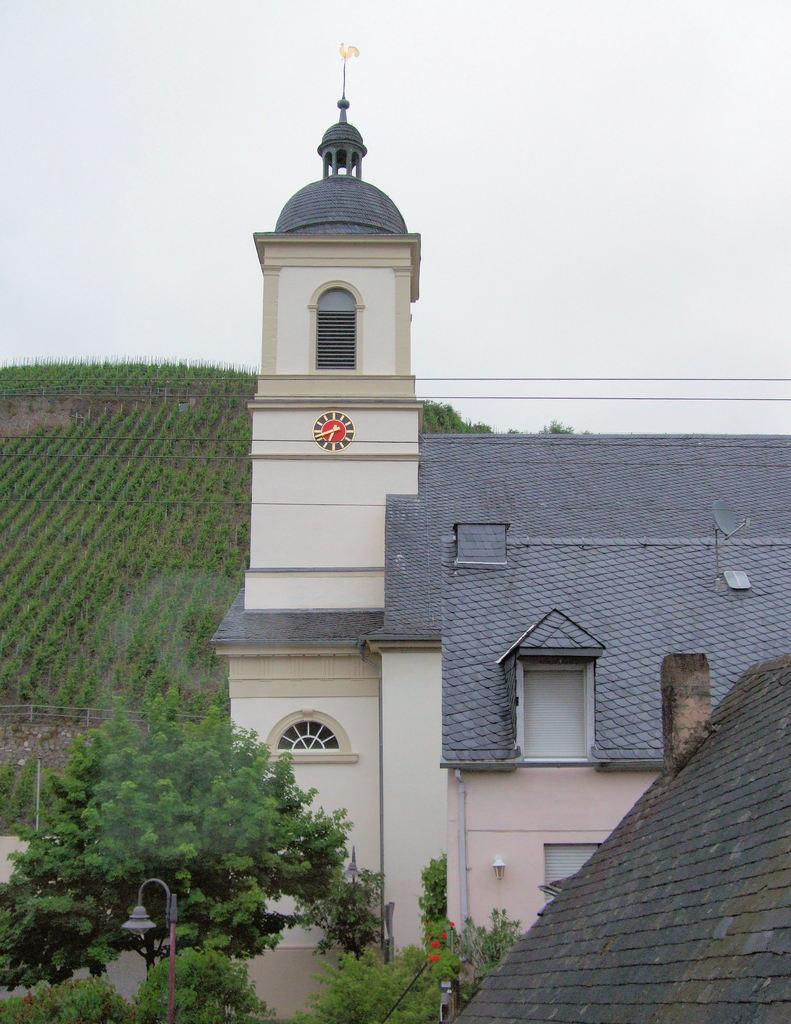What type of structures can be seen in the image? There are buildings in the image. What natural elements are present in the image? There are trees in the image. What object can be seen standing upright in the image? There is a pole in the image. What can be seen in the background of the image? There are plants and the sky visible in the background of the image. How many shoes can be seen on the pole in the image? There are no shoes present in the image, and the pole does not have any shoes attached to it. 